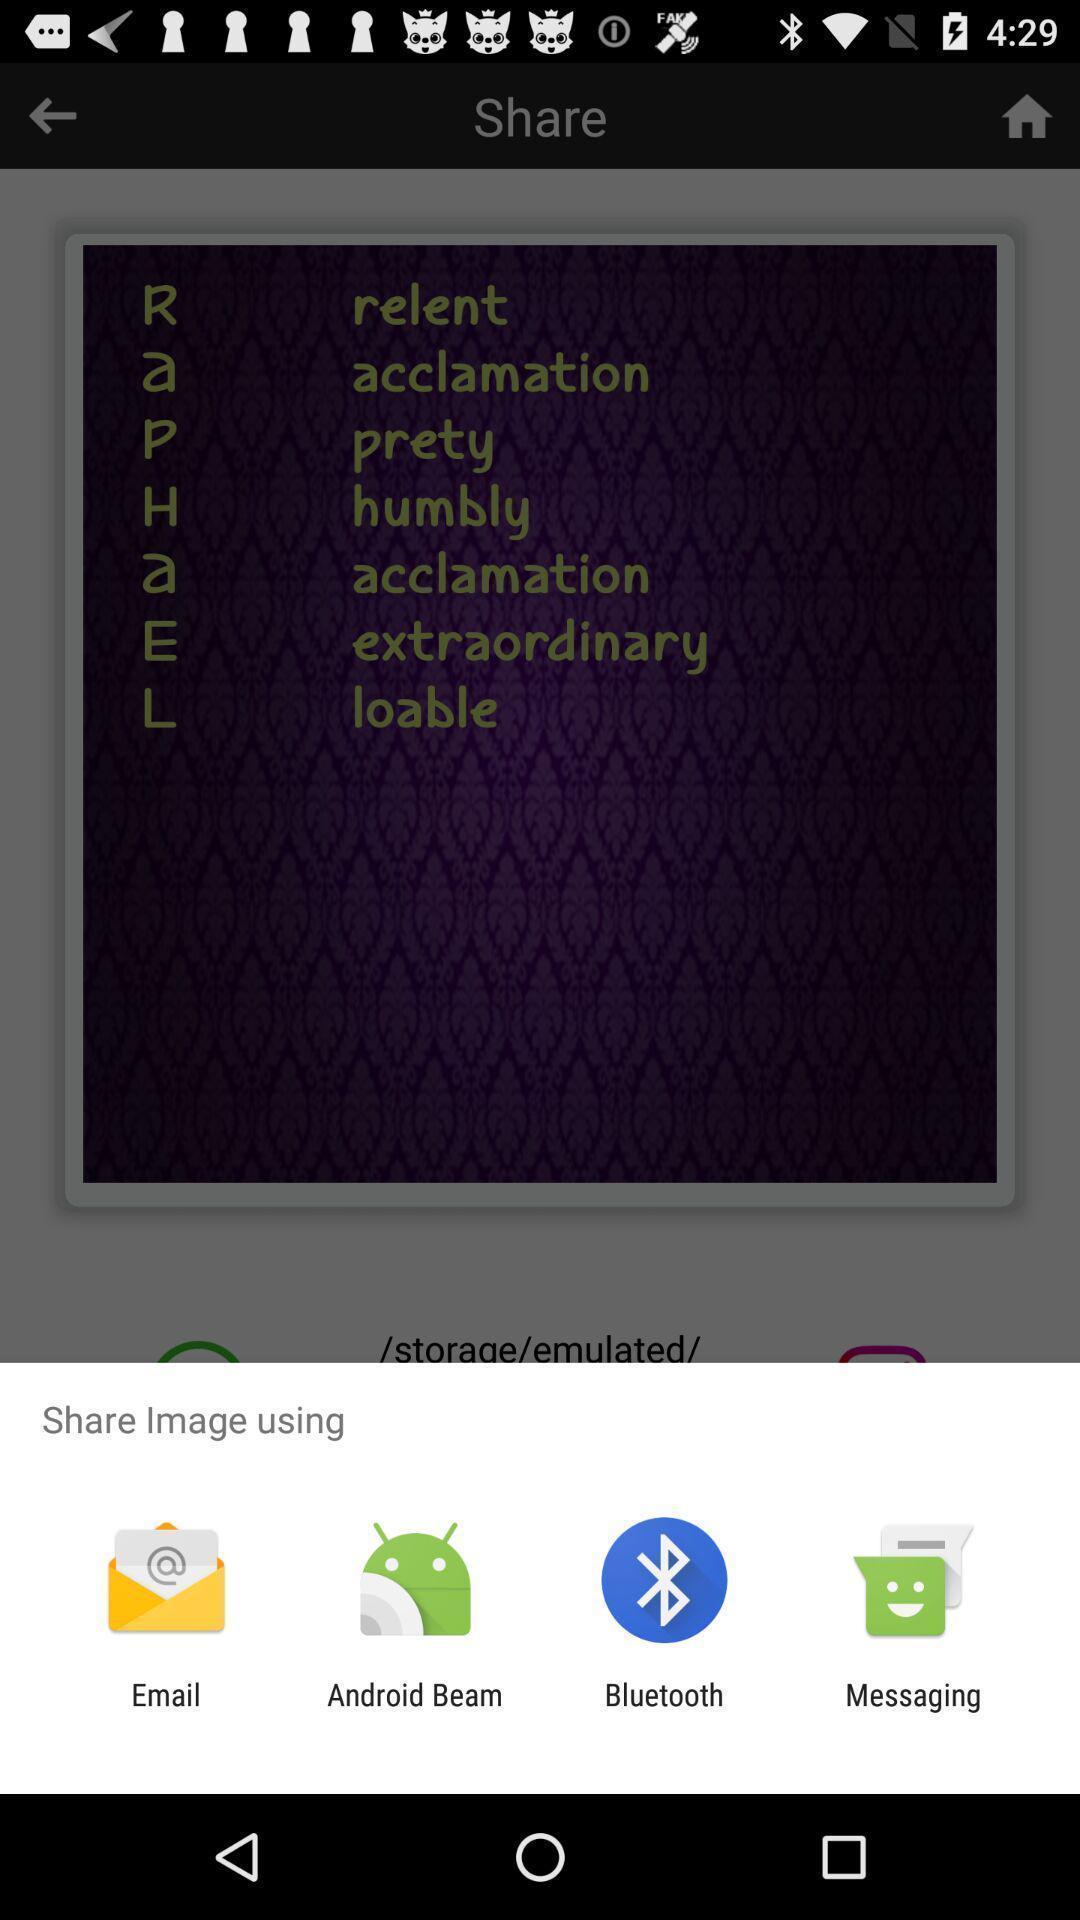Describe the content in this image. Pop-up displaying to select an app to share an image. 